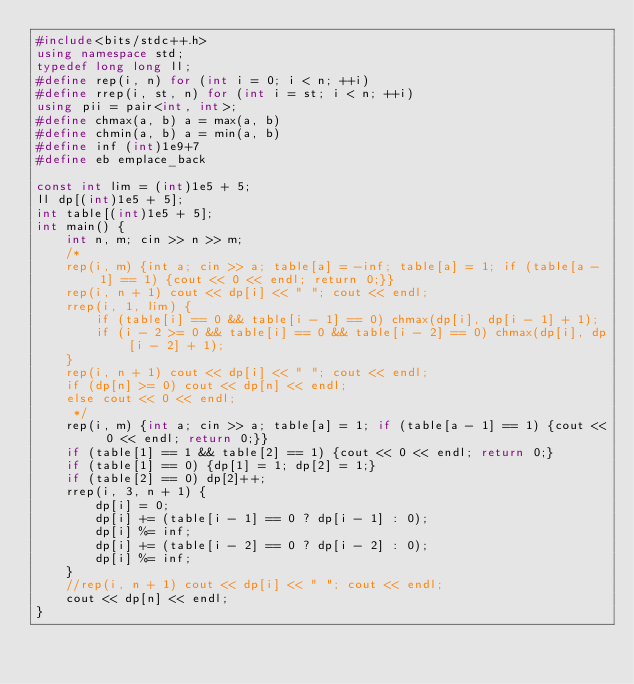<code> <loc_0><loc_0><loc_500><loc_500><_C++_>#include<bits/stdc++.h>
using namespace std;
typedef long long ll;
#define rep(i, n) for (int i = 0; i < n; ++i)
#define rrep(i, st, n) for (int i = st; i < n; ++i)
using pii = pair<int, int>;
#define chmax(a, b) a = max(a, b)
#define chmin(a, b) a = min(a, b)
#define inf (int)1e9+7
#define eb emplace_back

const int lim = (int)1e5 + 5;
ll dp[(int)1e5 + 5];
int table[(int)1e5 + 5];
int main() {
    int n, m; cin >> n >> m;
    /*
    rep(i, m) {int a; cin >> a; table[a] = -inf; table[a] = 1; if (table[a - 1] == 1) {cout << 0 << endl; return 0;}}
    rep(i, n + 1) cout << dp[i] << " "; cout << endl;
    rrep(i, 1, lim) {
        if (table[i] == 0 && table[i - 1] == 0) chmax(dp[i], dp[i - 1] + 1);
        if (i - 2 >= 0 && table[i] == 0 && table[i - 2] == 0) chmax(dp[i], dp[i - 2] + 1);
    }
    rep(i, n + 1) cout << dp[i] << " "; cout << endl;
    if (dp[n] >= 0) cout << dp[n] << endl;
    else cout << 0 << endl;
     */
    rep(i, m) {int a; cin >> a; table[a] = 1; if (table[a - 1] == 1) {cout << 0 << endl; return 0;}}
    if (table[1] == 1 && table[2] == 1) {cout << 0 << endl; return 0;}
    if (table[1] == 0) {dp[1] = 1; dp[2] = 1;}
    if (table[2] == 0) dp[2]++;
    rrep(i, 3, n + 1) {
        dp[i] = 0;
        dp[i] += (table[i - 1] == 0 ? dp[i - 1] : 0);
        dp[i] %= inf;
        dp[i] += (table[i - 2] == 0 ? dp[i - 2] : 0);
        dp[i] %= inf;
    }
    //rep(i, n + 1) cout << dp[i] << " "; cout << endl;
    cout << dp[n] << endl;
}
</code> 